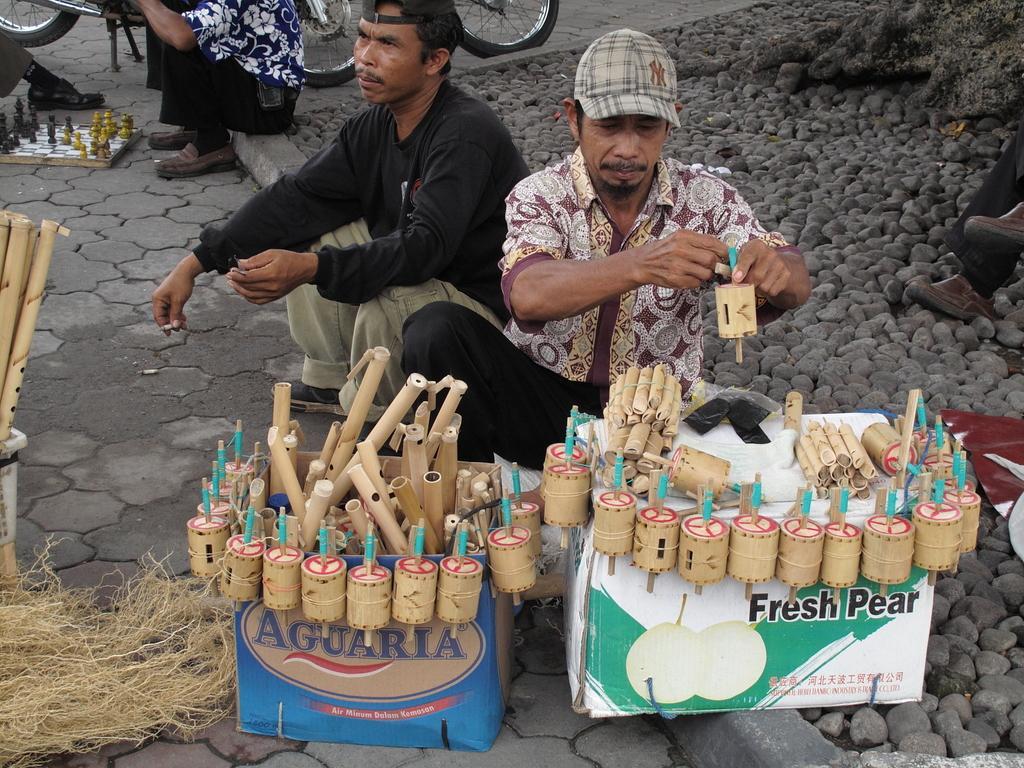Please provide a concise description of this image. In the image we can see there are people sitting, they are wearing clothes and a cap. There are boxes, stones, objects, chess board and chess coins. We can even see there is a vehicle. 